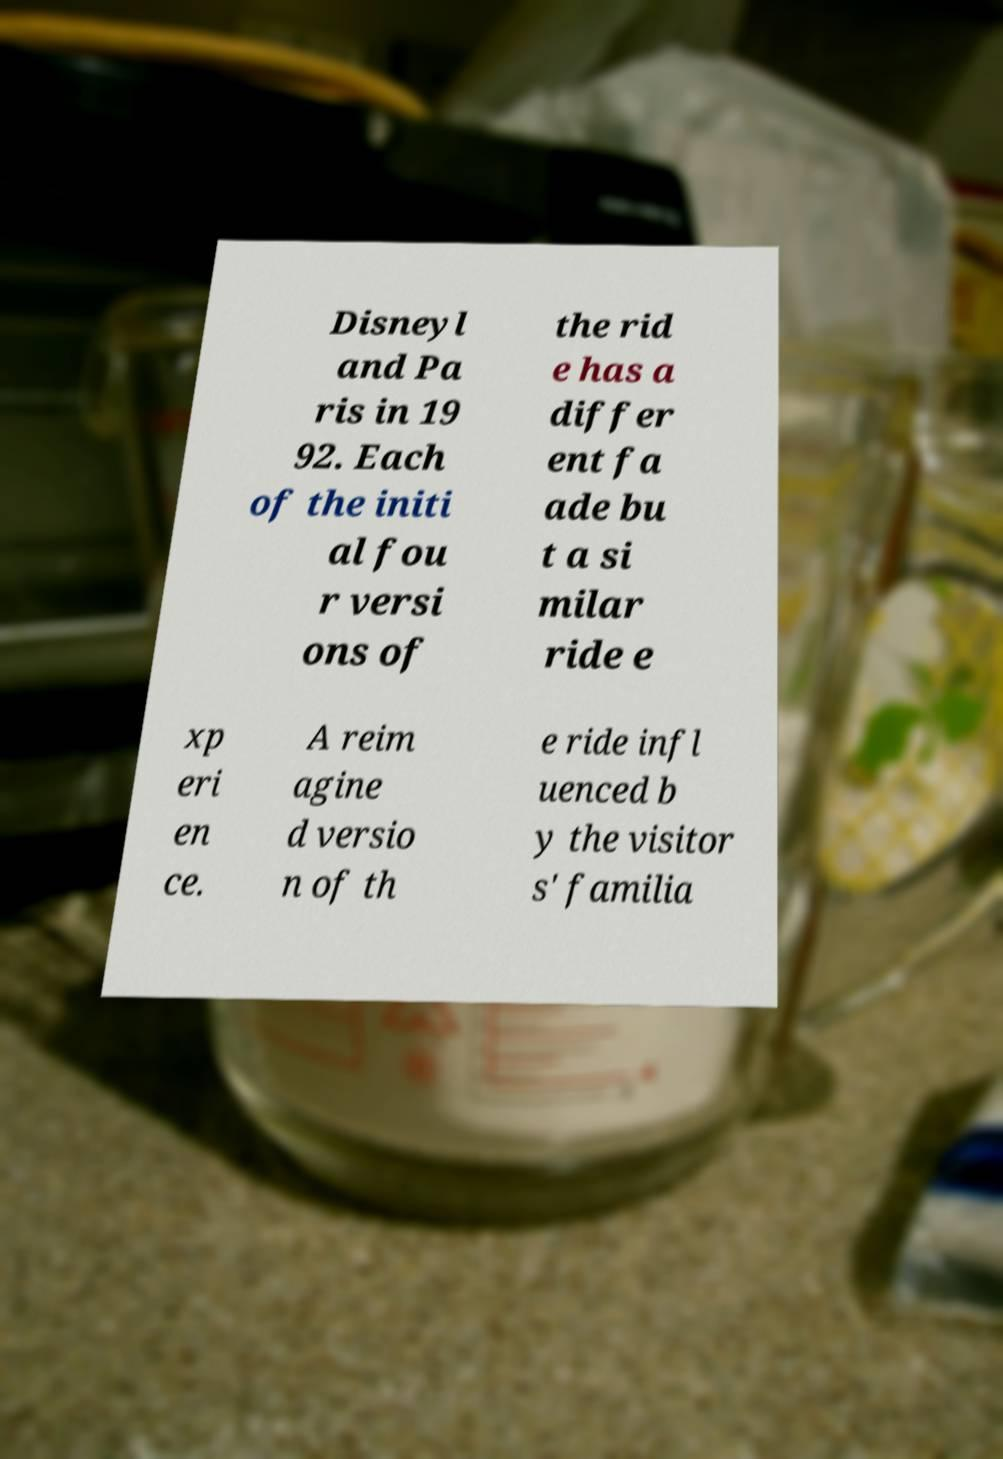What messages or text are displayed in this image? I need them in a readable, typed format. Disneyl and Pa ris in 19 92. Each of the initi al fou r versi ons of the rid e has a differ ent fa ade bu t a si milar ride e xp eri en ce. A reim agine d versio n of th e ride infl uenced b y the visitor s' familia 